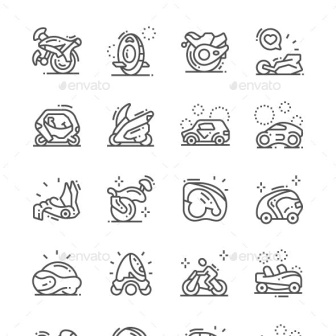Imagine these icons in a futuristic setting. How would the modes of transportation be different? Envision these icons in a futuristic setting where advanced technology has reshaped transportation. The motorcycle might be an anti-gravity bike, capable of hovering above ground and moving at incredible speeds. The unicycle could have evolved into a self-balancing personal transporter, equipped with smart sensors for navigation. The racecar could now be an autonomous hovercraft, capable of transforming its shape and function for different terrains. The futuristic enclosed vehicles might be autonomous pods that offer seamless connectivity and eco-friendly commuting. The jet ski could now operate both on water and in the air, providing an exhilarating experience of flying overland. Snowmobiles and sleds may be equipped with advanced climate controls and teleportation modules for instant travel. In such a scenario, every mode of transportation would integrate advanced AI, sustainable energy sources, and cutting-edge materials, revolutionizing the way we move. 